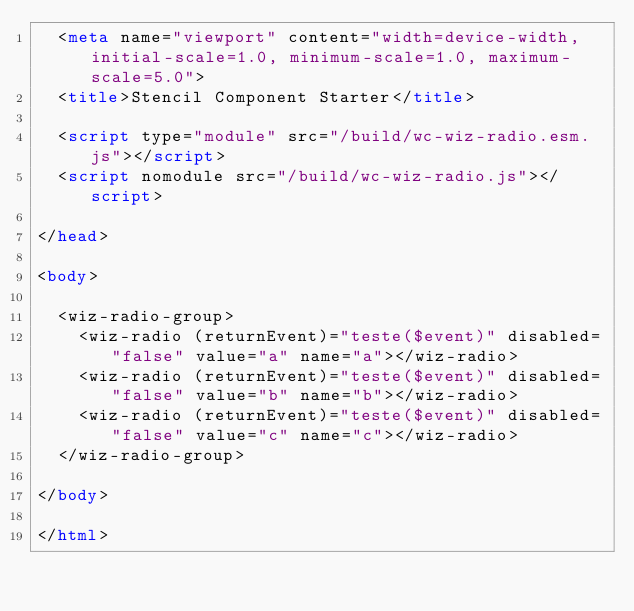<code> <loc_0><loc_0><loc_500><loc_500><_HTML_>  <meta name="viewport" content="width=device-width, initial-scale=1.0, minimum-scale=1.0, maximum-scale=5.0">
  <title>Stencil Component Starter</title>

  <script type="module" src="/build/wc-wiz-radio.esm.js"></script>
  <script nomodule src="/build/wc-wiz-radio.js"></script>

</head>

<body>

  <wiz-radio-group>
    <wiz-radio (returnEvent)="teste($event)" disabled="false" value="a" name="a"></wiz-radio>
    <wiz-radio (returnEvent)="teste($event)" disabled="false" value="b" name="b"></wiz-radio>
    <wiz-radio (returnEvent)="teste($event)" disabled="false" value="c" name="c"></wiz-radio>
  </wiz-radio-group>

</body>

</html>
</code> 